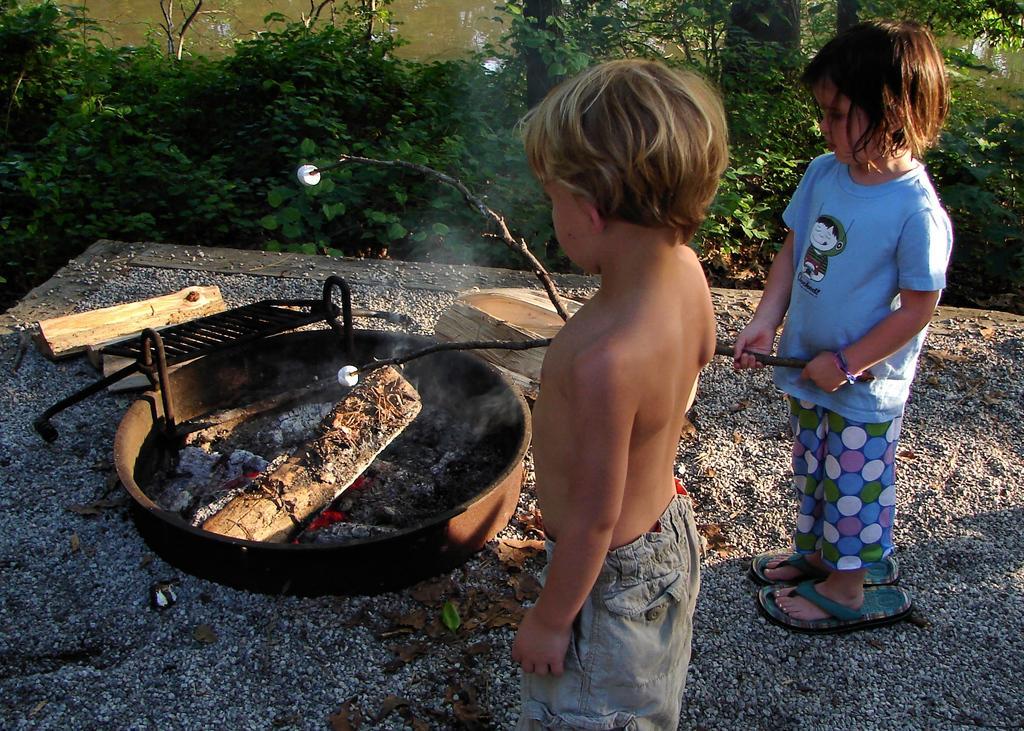In one or two sentences, can you explain what this image depicts? In the picture we can see a boy and a girl standing near the dish in it, we can see a wood and charcoal with lot of fire and behind it we can see plants. 